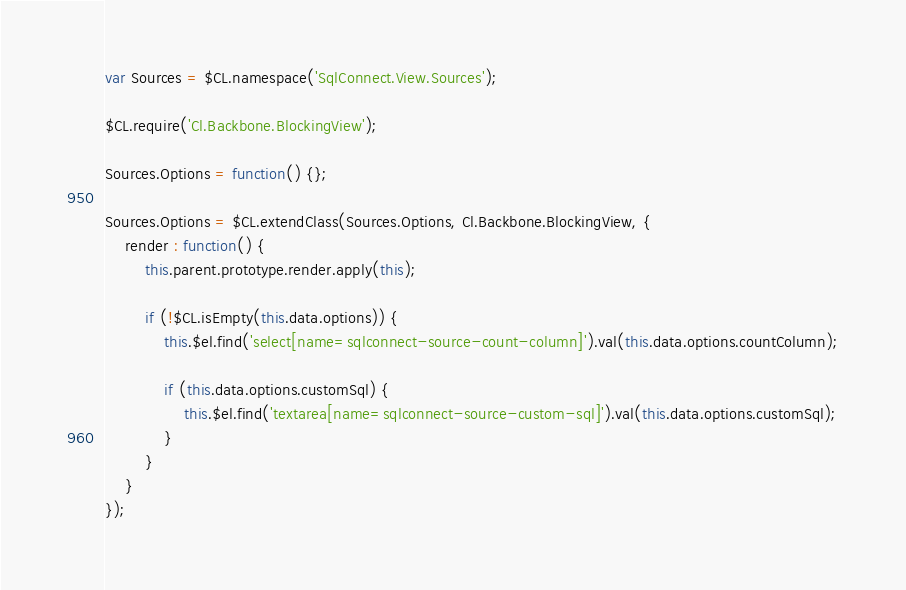<code> <loc_0><loc_0><loc_500><loc_500><_JavaScript_>var Sources = $CL.namespace('SqlConnect.View.Sources');

$CL.require('Cl.Backbone.BlockingView');

Sources.Options = function() {};

Sources.Options = $CL.extendClass(Sources.Options, Cl.Backbone.BlockingView, {
    render : function() {
        this.parent.prototype.render.apply(this);

        if (!$CL.isEmpty(this.data.options)) {
            this.$el.find('select[name=sqlconnect-source-count-column]').val(this.data.options.countColumn);
            
            if (this.data.options.customSql) {
                this.$el.find('textarea[name=sqlconnect-source-custom-sql]').val(this.data.options.customSql);
            }
        }
    }
});
</code> 